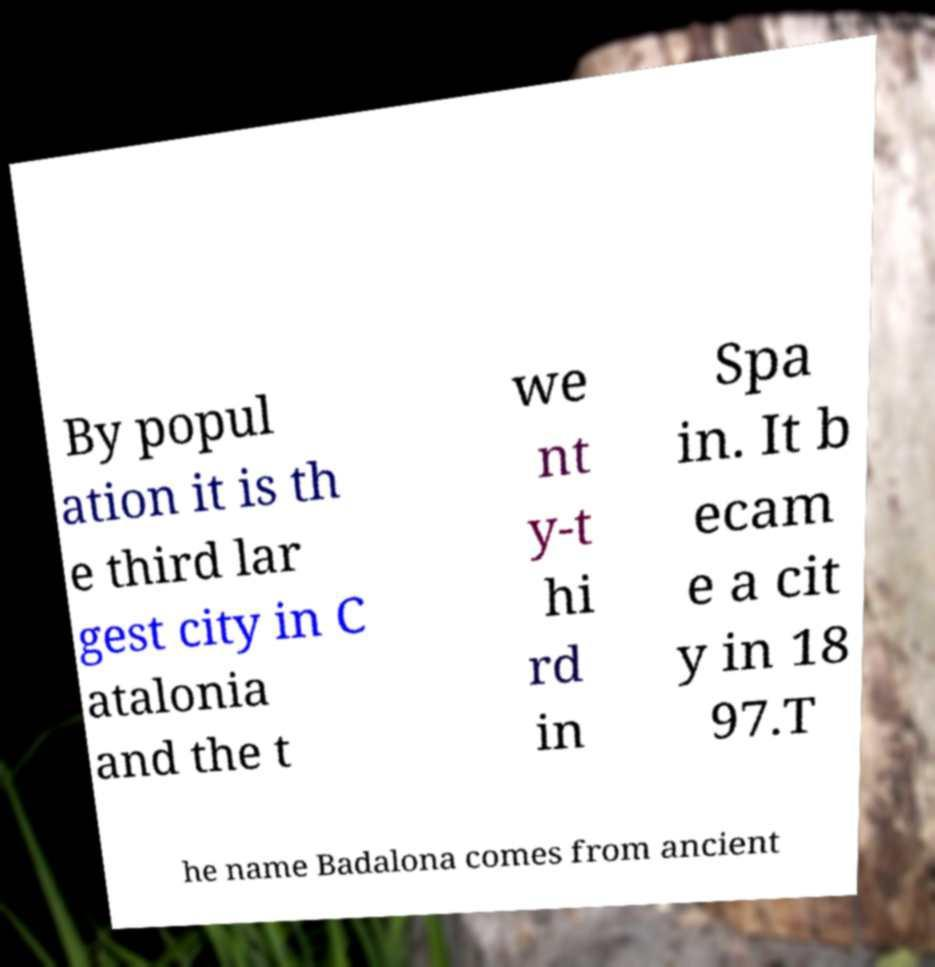Can you read and provide the text displayed in the image?This photo seems to have some interesting text. Can you extract and type it out for me? By popul ation it is th e third lar gest city in C atalonia and the t we nt y-t hi rd in Spa in. It b ecam e a cit y in 18 97.T he name Badalona comes from ancient 